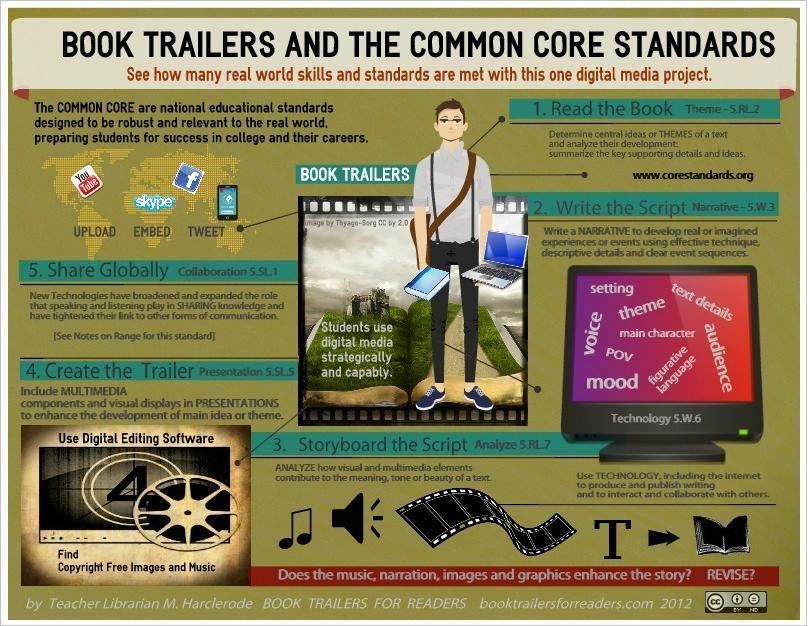What is the word related to skype?
Answer the question with a short phrase. Embed How many words are in this computer? 12 